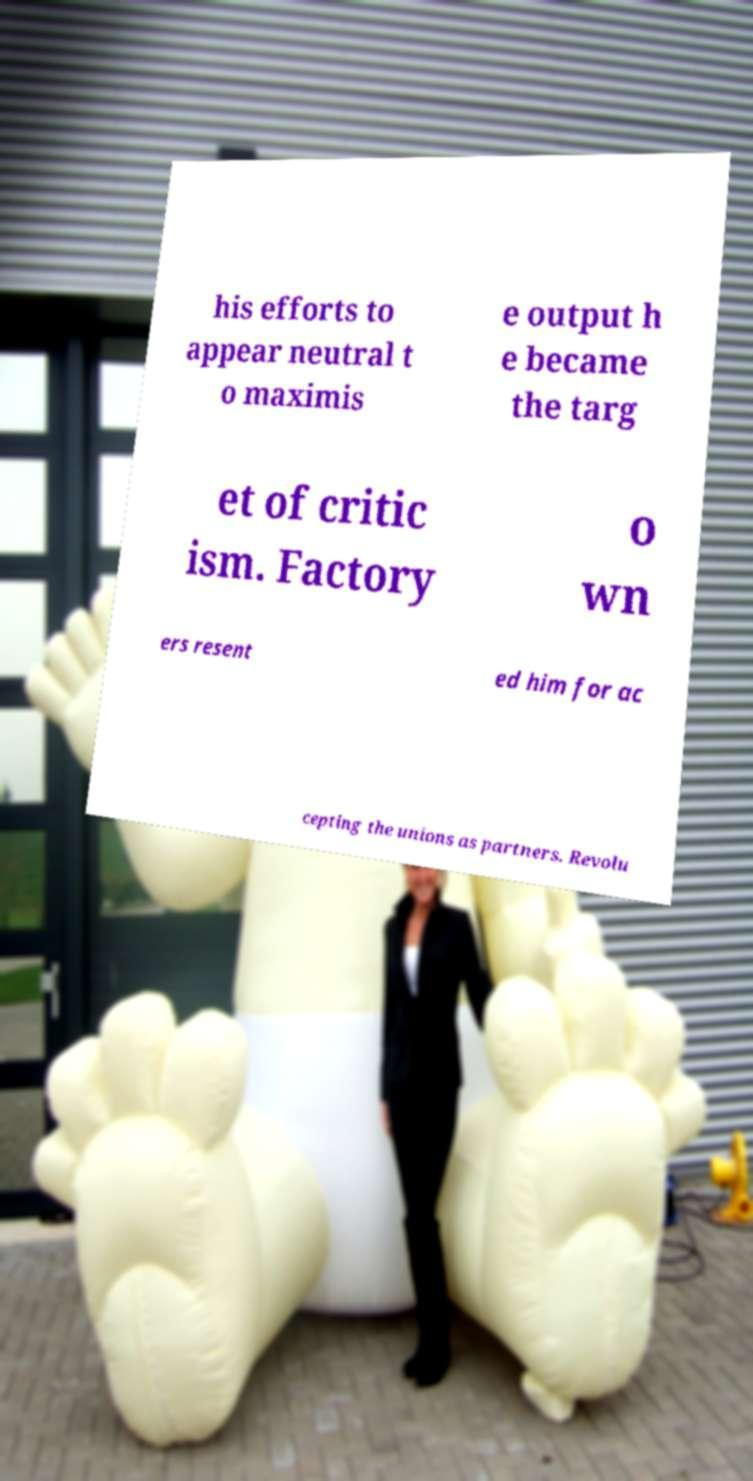Please identify and transcribe the text found in this image. his efforts to appear neutral t o maximis e output h e became the targ et of critic ism. Factory o wn ers resent ed him for ac cepting the unions as partners. Revolu 